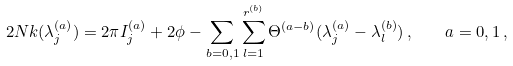Convert formula to latex. <formula><loc_0><loc_0><loc_500><loc_500>2 N k ( \lambda _ { j } ^ { ( a ) } ) = 2 \pi I _ { j } ^ { ( a ) } + 2 \phi - \sum _ { b = 0 , 1 } \sum _ { l = 1 } ^ { r ^ { ( b ) } } \Theta ^ { ( a - b ) } ( \lambda _ { j } ^ { ( a ) } - \lambda _ { l } ^ { ( b ) } ) \, , \quad a = 0 , 1 \, ,</formula> 